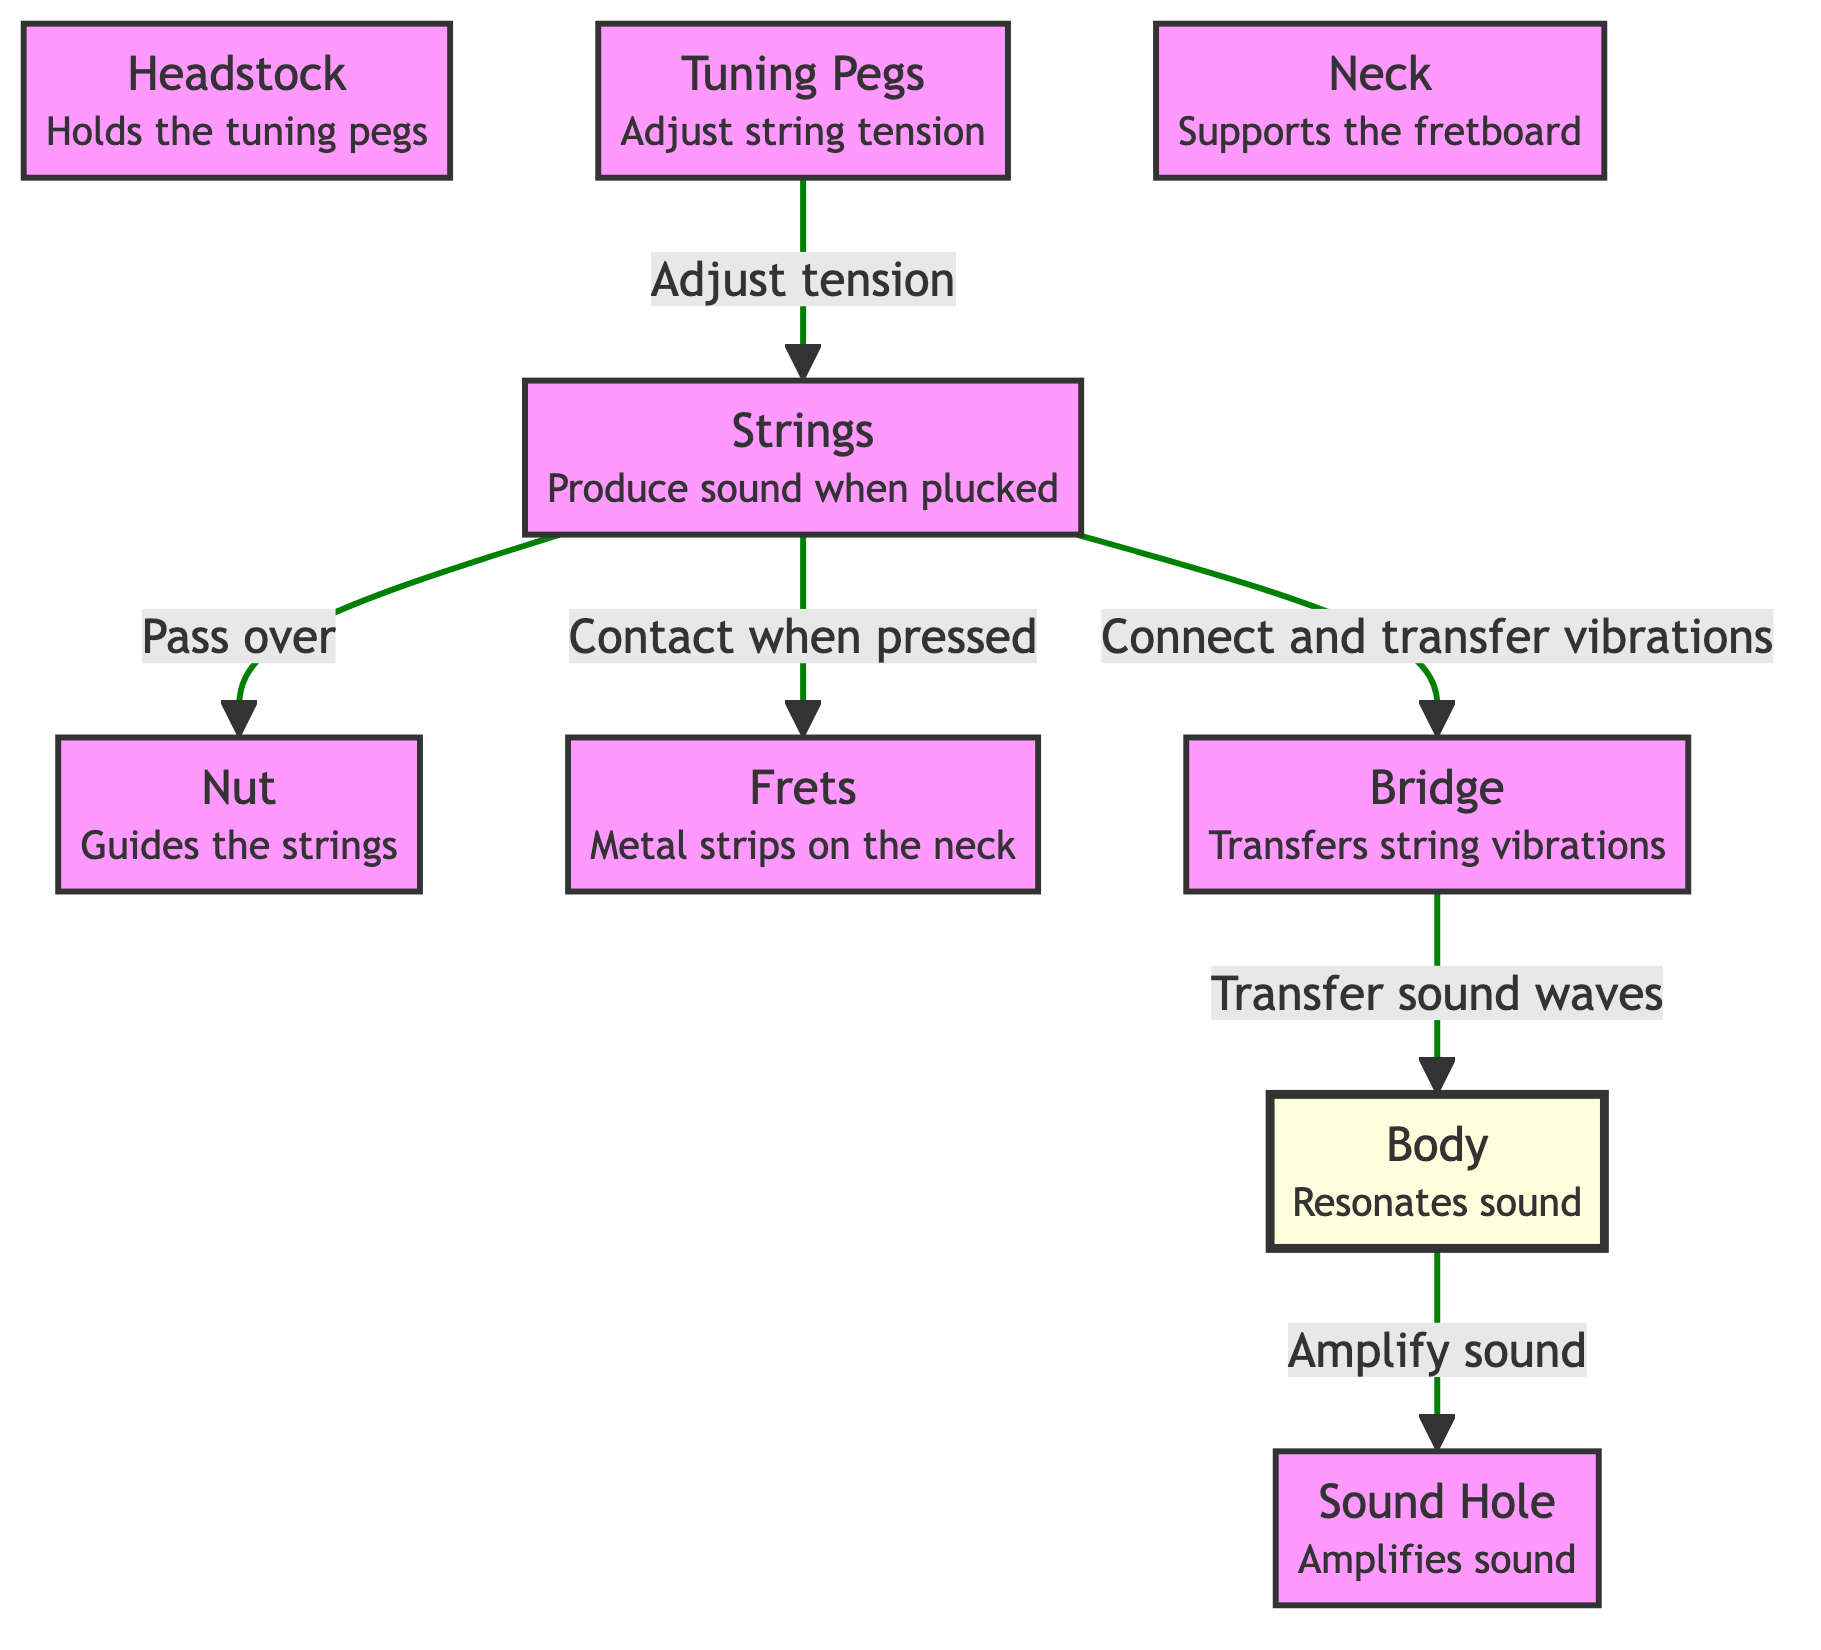What does the headstock hold? The headstock is responsible for holding the tuning pegs. This is a direct statement from the information provided in the diagram.
Answer: Tuning pegs How many components are involved in string tension adjustment? The single connection involving tuning pegs and strings indicates that there is one component, the tuning pegs, that adjusts string tension.
Answer: One Which part guides the strings? According to the diagram, the nut is explicitly mentioned as the part that guides the strings.
Answer: Nut What is the function of the bridge? The bridge is described in the diagram as transferring string vibrations, indicating its role in sound production from the strings to the body.
Answer: Transfers string vibrations What flows from the body to amplify sound? The relationship shown in the diagram states that sound waves flow from the bridge to the body, where the body then amplifies the sound, with the sound hole being involved in this process.
Answer: Sound waves Which two parts are responsible for sound amplification? By observing the diagram, it confirms that both the body and the sound hole play a role in sound amplification. The body's function is to resonate sound, while the sound hole amplifies it further.
Answer: Body and sound hole What is the relationship between the strings and frets? The diagram indicates that the strings contact the frets when pressed, showing a direct interaction needed for sound modulation and pitch change.
Answer: Contact when pressed How do the strings interact with the nut? The relationship shows the strings passing over the nut as they are guided, establishing a direct connection that influences string positioning.
Answer: Pass over What is the primary role of the body in sound production? The diagram clearly indicates that the body resonates sound, making it a crucial part of the acoustic guitar's sound production ability.
Answer: Resonates sound 